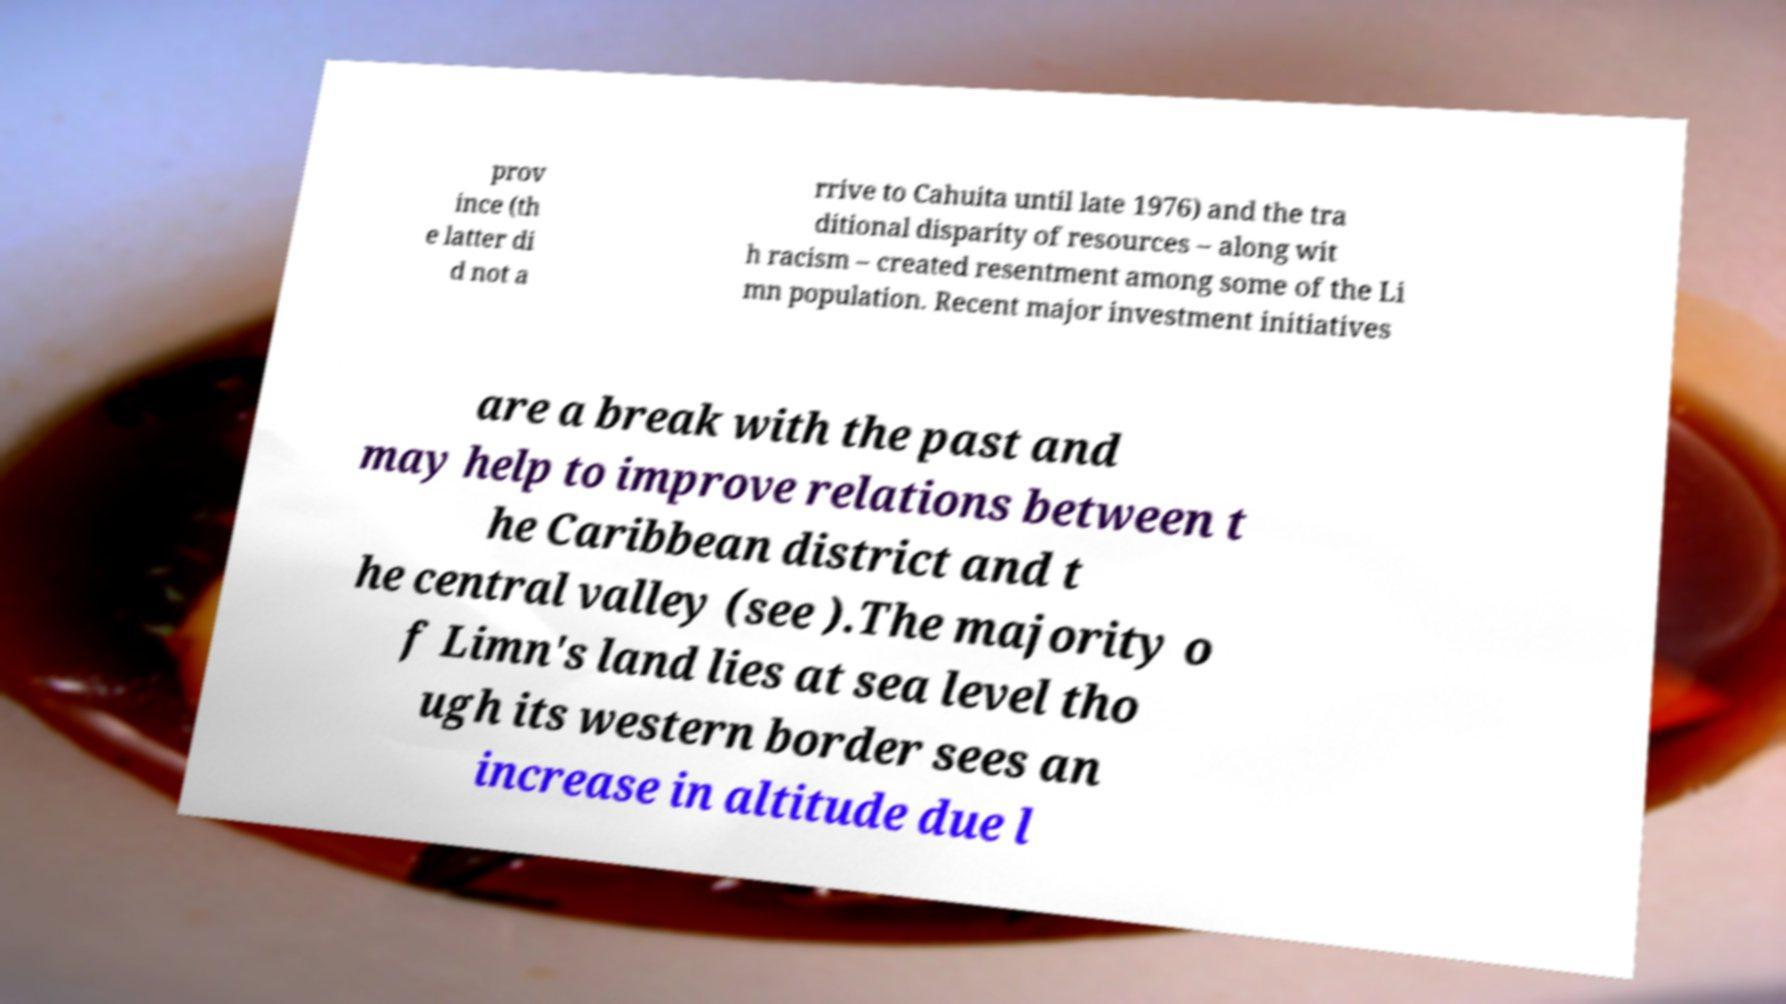Could you assist in decoding the text presented in this image and type it out clearly? prov ince (th e latter di d not a rrive to Cahuita until late 1976) and the tra ditional disparity of resources – along wit h racism – created resentment among some of the Li mn population. Recent major investment initiatives are a break with the past and may help to improve relations between t he Caribbean district and t he central valley (see ).The majority o f Limn's land lies at sea level tho ugh its western border sees an increase in altitude due l 